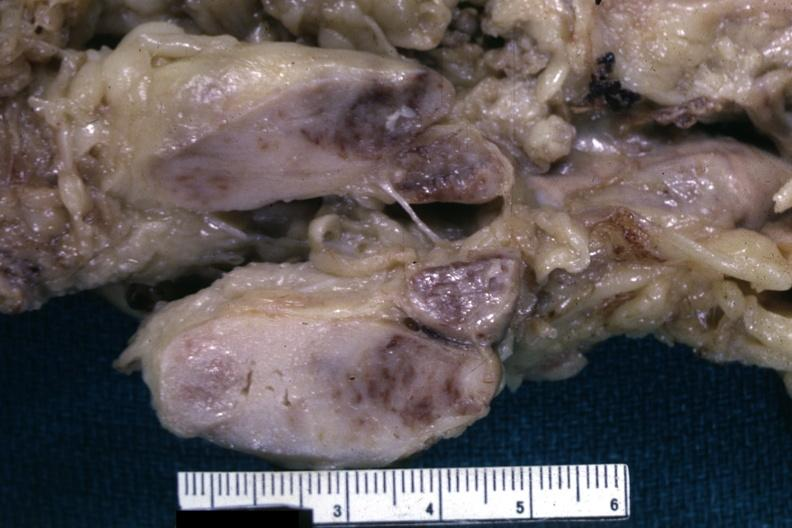how is matting history of this case could have been a seminoma see other slides?
Answer the question using a single word or phrase. Unknown 